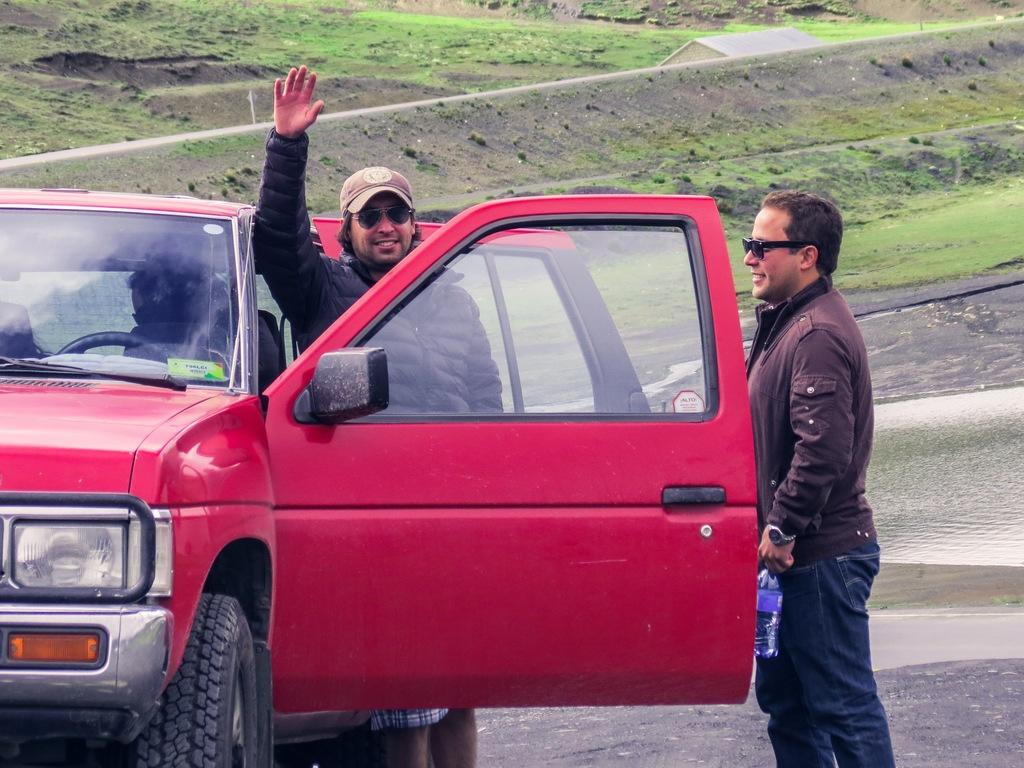What type of vegetation is present in the image? There is grass in the image. What are the two persons doing in the image? The two persons are standing on the road. What object can be seen in the image that might be used for holding a liquid? There is a bottle visible in the image. What type of vehicle is present in the image? There is a car in the image. What type of insurance policy is being discussed by the persons in the image? There is no indication in the image that the persons are discussing any insurance policies. 